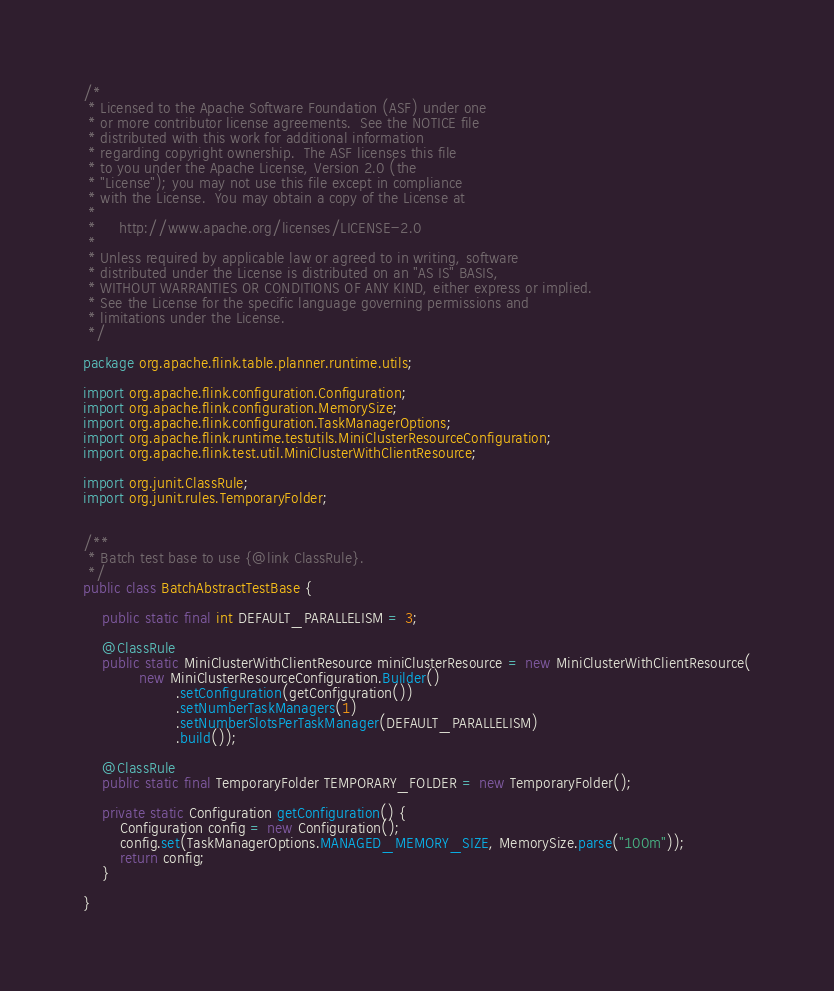Convert code to text. <code><loc_0><loc_0><loc_500><loc_500><_Java_>/*
 * Licensed to the Apache Software Foundation (ASF) under one
 * or more contributor license agreements.  See the NOTICE file
 * distributed with this work for additional information
 * regarding copyright ownership.  The ASF licenses this file
 * to you under the Apache License, Version 2.0 (the
 * "License"); you may not use this file except in compliance
 * with the License.  You may obtain a copy of the License at
 *
 *     http://www.apache.org/licenses/LICENSE-2.0
 *
 * Unless required by applicable law or agreed to in writing, software
 * distributed under the License is distributed on an "AS IS" BASIS,
 * WITHOUT WARRANTIES OR CONDITIONS OF ANY KIND, either express or implied.
 * See the License for the specific language governing permissions and
 * limitations under the License.
 */

package org.apache.flink.table.planner.runtime.utils;

import org.apache.flink.configuration.Configuration;
import org.apache.flink.configuration.MemorySize;
import org.apache.flink.configuration.TaskManagerOptions;
import org.apache.flink.runtime.testutils.MiniClusterResourceConfiguration;
import org.apache.flink.test.util.MiniClusterWithClientResource;

import org.junit.ClassRule;
import org.junit.rules.TemporaryFolder;


/**
 * Batch test base to use {@link ClassRule}.
 */
public class BatchAbstractTestBase {

	public static final int DEFAULT_PARALLELISM = 3;

	@ClassRule
	public static MiniClusterWithClientResource miniClusterResource = new MiniClusterWithClientResource(
			new MiniClusterResourceConfiguration.Builder()
					.setConfiguration(getConfiguration())
					.setNumberTaskManagers(1)
					.setNumberSlotsPerTaskManager(DEFAULT_PARALLELISM)
					.build());

	@ClassRule
	public static final TemporaryFolder TEMPORARY_FOLDER = new TemporaryFolder();

	private static Configuration getConfiguration() {
		Configuration config = new Configuration();
		config.set(TaskManagerOptions.MANAGED_MEMORY_SIZE, MemorySize.parse("100m"));
		return config;
	}

}
</code> 